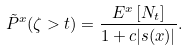<formula> <loc_0><loc_0><loc_500><loc_500>\tilde { P } ^ { x } ( \zeta > t ) = \frac { E ^ { x } \left [ N _ { t } \right ] } { 1 + c | s ( x ) | } .</formula> 